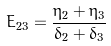<formula> <loc_0><loc_0><loc_500><loc_500>E _ { 2 3 } = \frac { \eta _ { 2 } + \eta _ { 3 } } { \delta _ { 2 } + \delta _ { 3 } }</formula> 